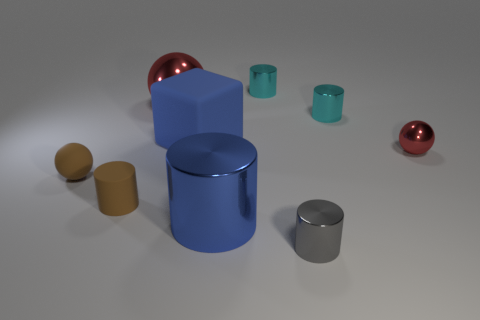Subtract all brown cylinders. How many cylinders are left? 4 Subtract all blue cylinders. How many cylinders are left? 4 Subtract all yellow cylinders. Subtract all purple spheres. How many cylinders are left? 5 Subtract all cylinders. How many objects are left? 4 Add 6 small brown matte things. How many small brown matte things exist? 8 Subtract 1 brown cylinders. How many objects are left? 8 Subtract all blue cylinders. Subtract all tiny brown rubber things. How many objects are left? 6 Add 2 tiny red metal things. How many tiny red metal things are left? 3 